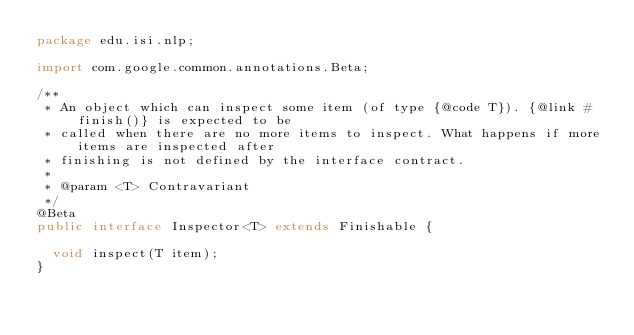<code> <loc_0><loc_0><loc_500><loc_500><_Java_>package edu.isi.nlp;

import com.google.common.annotations.Beta;

/**
 * An object which can inspect some item (of type {@code T}). {@link #finish()} is expected to be
 * called when there are no more items to inspect. What happens if more items are inspected after
 * finishing is not defined by the interface contract.
 *
 * @param <T> Contravariant
 */
@Beta
public interface Inspector<T> extends Finishable {

  void inspect(T item);
}
</code> 